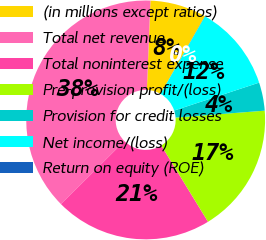<chart> <loc_0><loc_0><loc_500><loc_500><pie_chart><fcel>(in millions except ratios)<fcel>Total net revenue<fcel>Total noninterest expense<fcel>Pre-provision profit/(loss)<fcel>Provision for credit losses<fcel>Net income/(loss)<fcel>Return on equity (ROE)<nl><fcel>7.63%<fcel>38.09%<fcel>21.29%<fcel>17.49%<fcel>3.82%<fcel>11.66%<fcel>0.02%<nl></chart> 